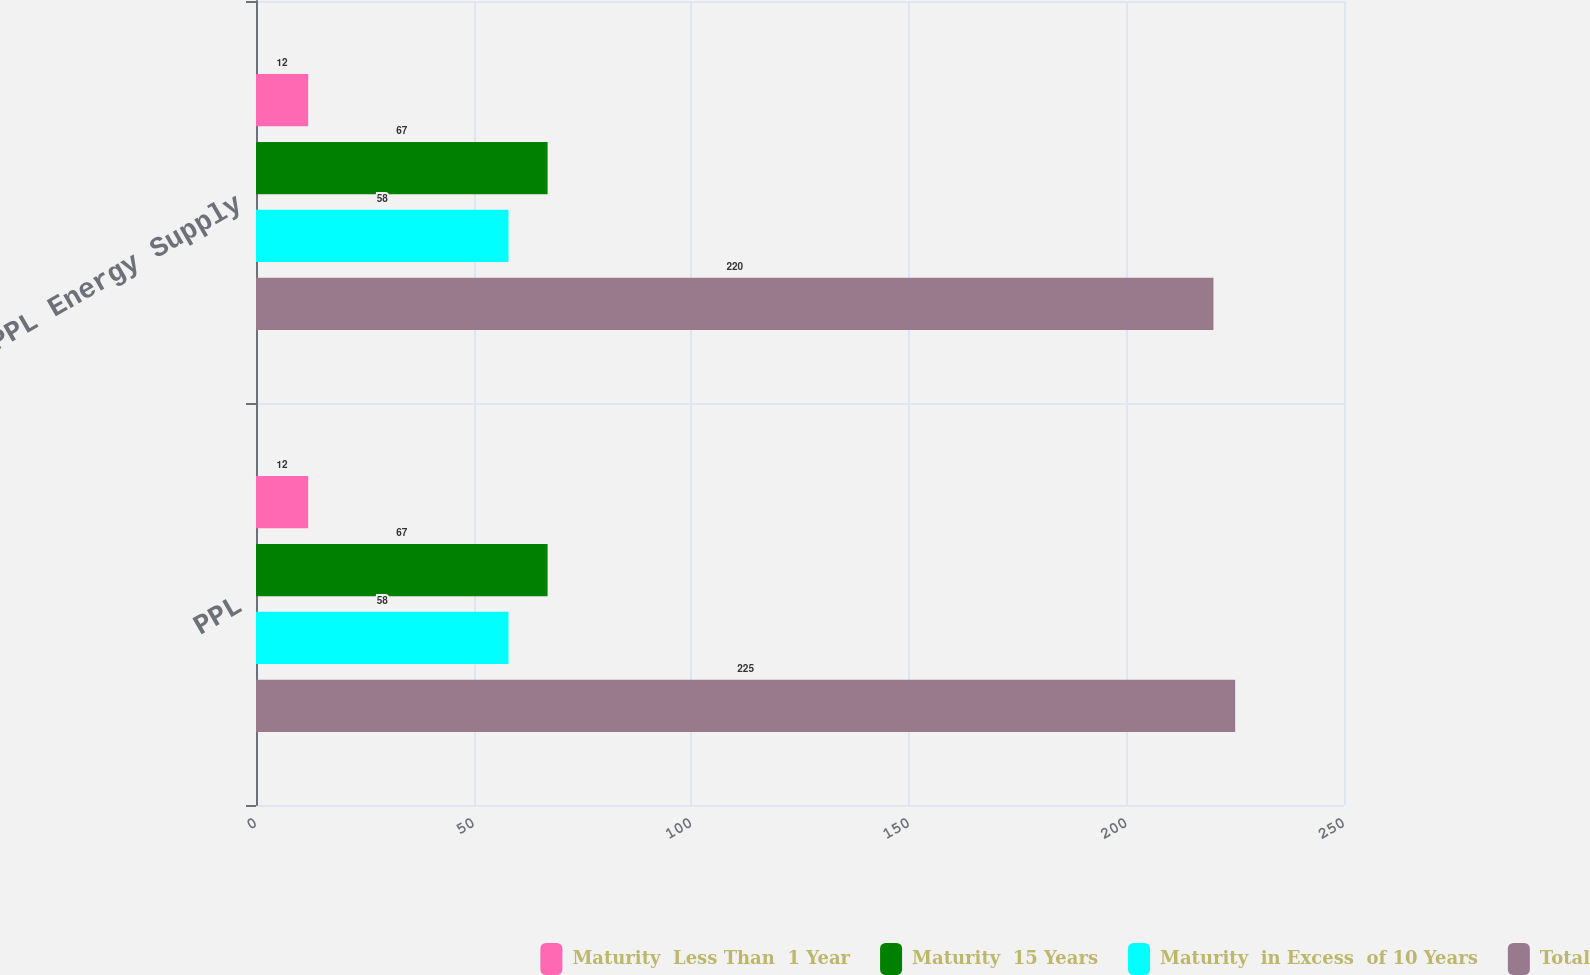Convert chart. <chart><loc_0><loc_0><loc_500><loc_500><stacked_bar_chart><ecel><fcel>PPL<fcel>PPL Energy Supply<nl><fcel>Maturity  Less Than  1 Year<fcel>12<fcel>12<nl><fcel>Maturity  15 Years<fcel>67<fcel>67<nl><fcel>Maturity  in Excess  of 10 Years<fcel>58<fcel>58<nl><fcel>Total<fcel>225<fcel>220<nl></chart> 